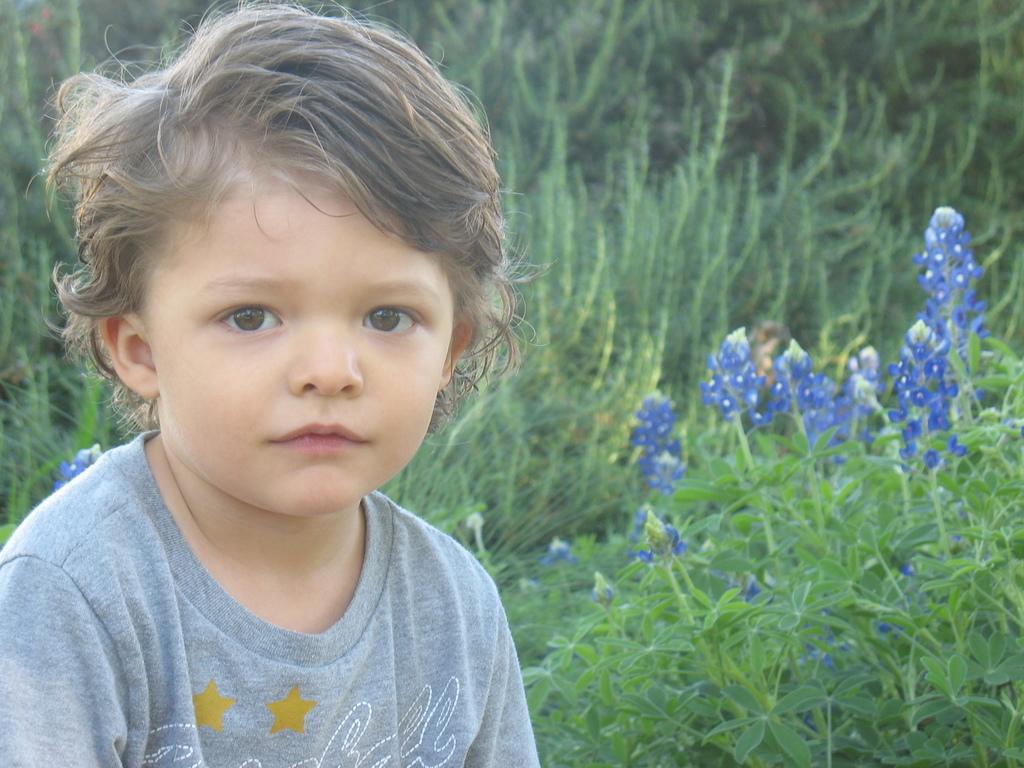How would you summarize this image in a sentence or two? In this image, I can see a boy with a T-shirt. These are the plants with the flowers, which are blue in color. In the background, these look like the trees. 